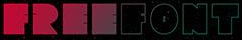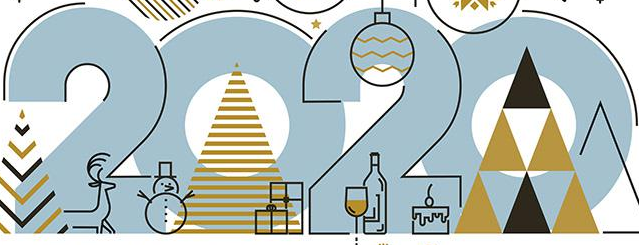Identify the words shown in these images in order, separated by a semicolon. FREEFONT; 2020 